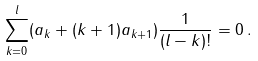<formula> <loc_0><loc_0><loc_500><loc_500>\sum _ { k = 0 } ^ { l } ( a _ { k } + ( k + 1 ) a _ { k + 1 } ) \frac { 1 } { ( l - k ) ! } = 0 \, .</formula> 